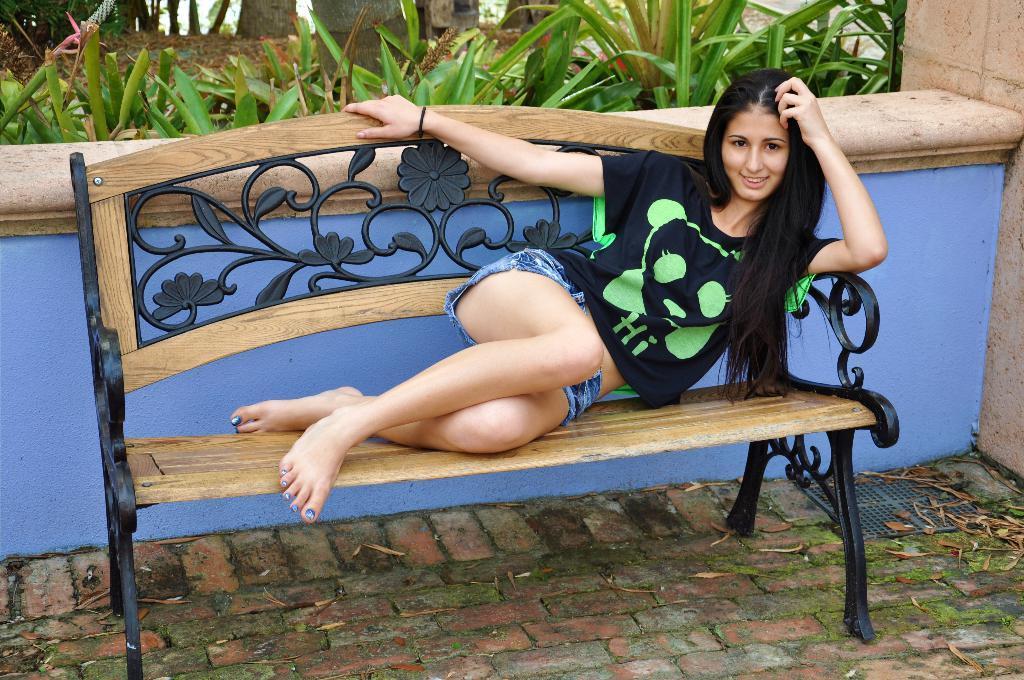In one or two sentences, can you explain what this image depicts? Woman in black t-shirt is lying on bench and she is smiling. Behind her, we see a blue wall and behind that, we see many plants in the garden. 